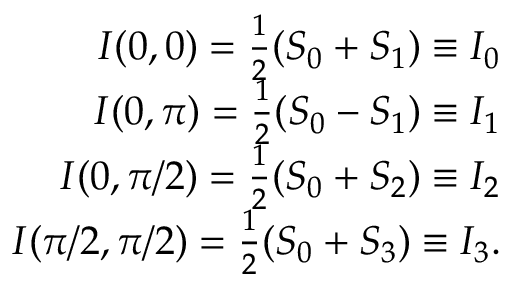<formula> <loc_0><loc_0><loc_500><loc_500>\begin{array} { r l r } & { I ( 0 , 0 ) = \frac { 1 } { 2 } ( S _ { 0 } + S _ { 1 } ) \equiv I _ { 0 } } \\ & { I ( 0 , \pi ) = \frac { 1 } { 2 } ( S _ { 0 } - S _ { 1 } ) \equiv I _ { 1 } } \\ & { I ( 0 , \pi / 2 ) = \frac { 1 } { 2 } ( S _ { 0 } + S _ { 2 } ) \equiv I _ { 2 } } \\ & { I ( \pi / 2 , \pi / 2 ) = \frac { 1 } { 2 } ( S _ { 0 } + S _ { 3 } ) \equiv I _ { 3 } . } \end{array}</formula> 